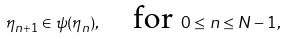<formula> <loc_0><loc_0><loc_500><loc_500>\eta _ { n + 1 } \in \psi ( \eta _ { n } ) , \quad \text {for } 0 \leq n \leq N - 1 ,</formula> 